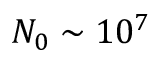Convert formula to latex. <formula><loc_0><loc_0><loc_500><loc_500>N _ { 0 } \sim 1 0 ^ { 7 }</formula> 